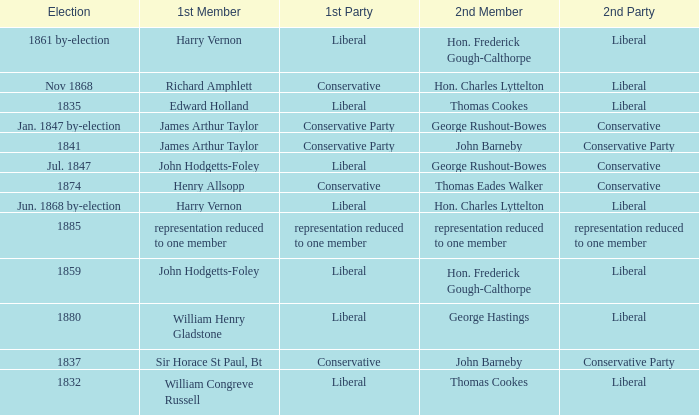What was the 2nd Party, when the 1st Member was John Hodgetts-Foley, and the 2nd Member was Hon. Frederick Gough-Calthorpe? Liberal. 